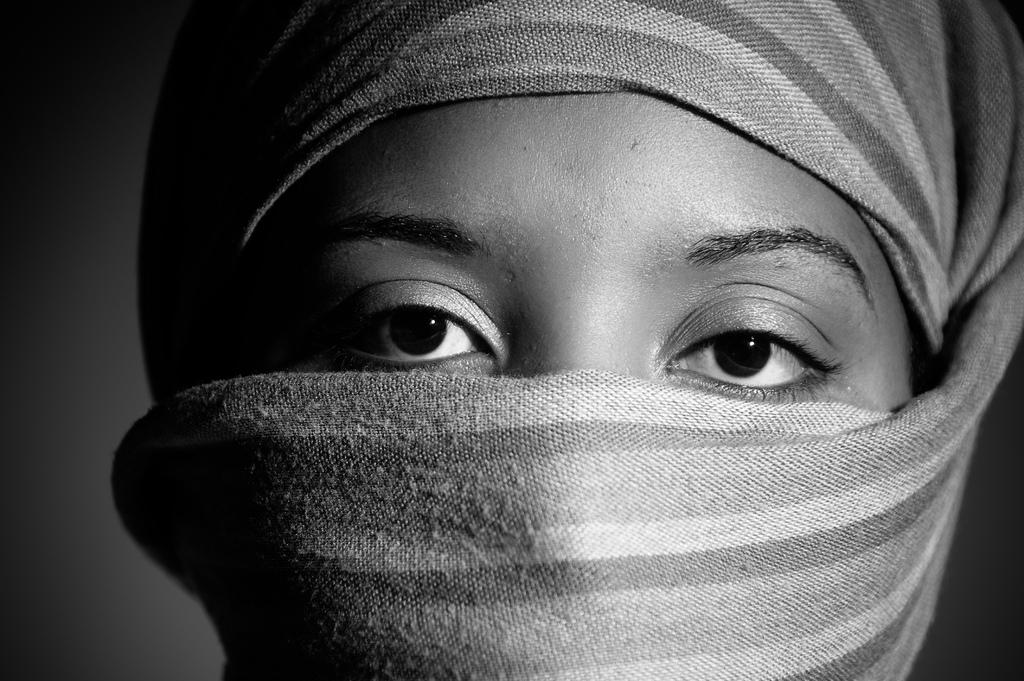What is the color scheme of the image? The image is black and white. Can you describe the person in the image? There is a lady in the image. What is the lady wearing on her face? The lady is wearing a mask. How many beds can be seen in the image? There are no beds present in the image. What type of motion is the lady performing in the image? The image is still, so there is no motion depicted. 